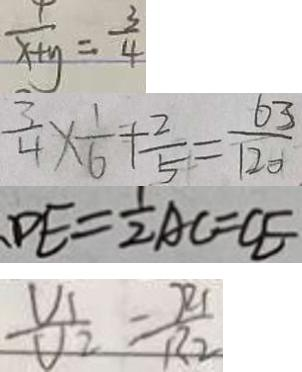Convert formula to latex. <formula><loc_0><loc_0><loc_500><loc_500>\frac { 1 } { x + y } = \frac { 3 } { 4 } 
 \frac { 3 } { 4 } \times \frac { 1 } { 6 } + \frac { 2 } { 5 } = \frac { 6 3 } { 1 2 0 } 
 D E = \frac { 1 } { 2 } A C = C E 
 \frac { V _ { 1 } } { V _ { 2 } } = \frac { R _ { 1 } } { R _ { 2 } }</formula> 